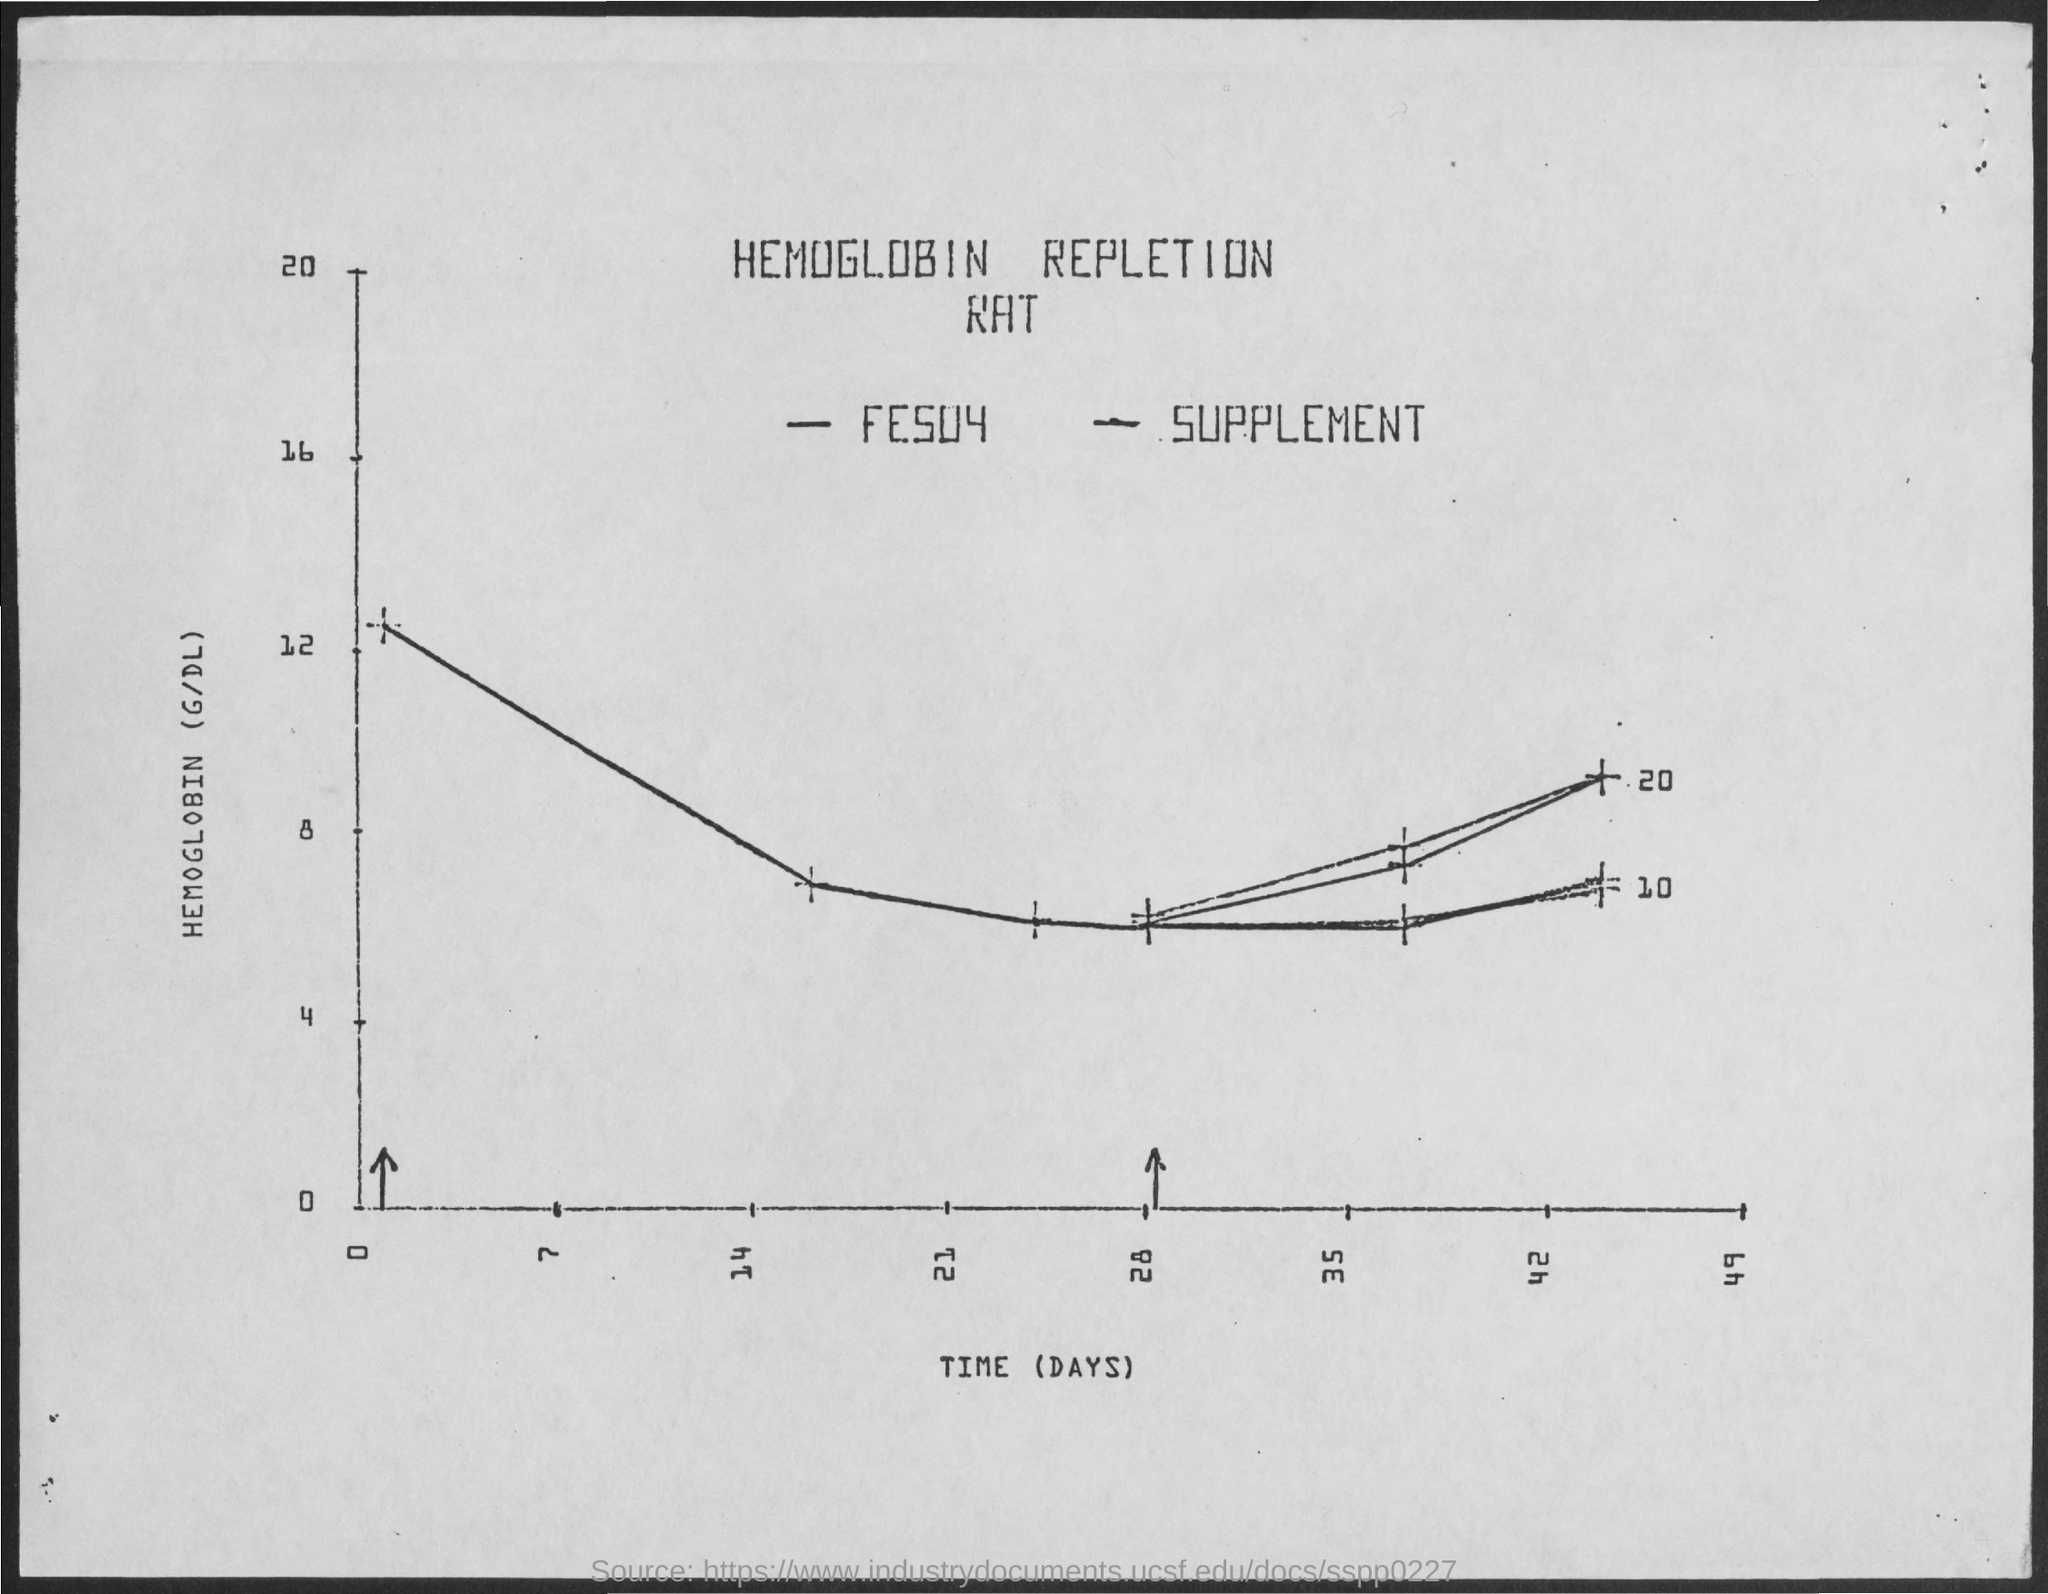What is plotted in the x-axis ?
Give a very brief answer. Time(Days). 